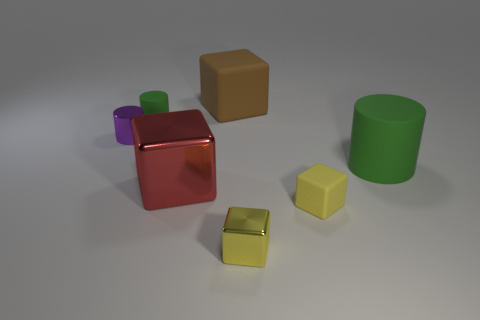Add 1 brown matte cubes. How many objects exist? 8 Subtract all large brown rubber cubes. How many cubes are left? 3 Subtract all red blocks. How many blocks are left? 3 Subtract all blue cylinders. How many yellow blocks are left? 2 Subtract all cubes. How many objects are left? 3 Add 7 red things. How many red things are left? 8 Add 3 blue metallic things. How many blue metallic things exist? 3 Subtract 0 gray cubes. How many objects are left? 7 Subtract 1 cylinders. How many cylinders are left? 2 Subtract all red blocks. Subtract all yellow cylinders. How many blocks are left? 3 